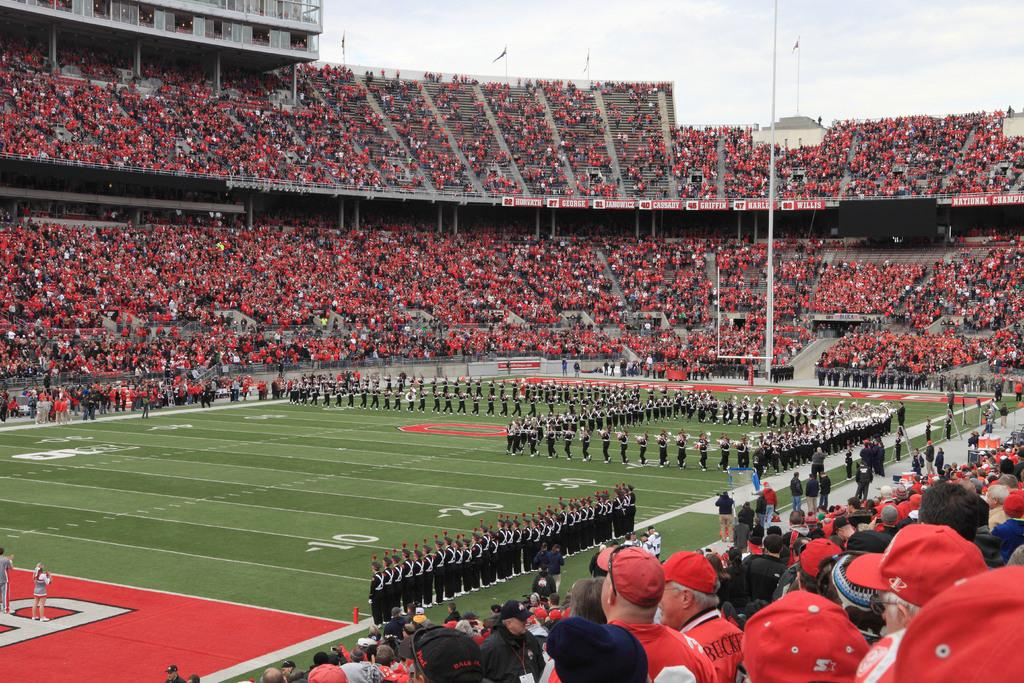What is the main subject of the image? The main subject of the image is a group of people on the ground. What objects can be seen in the image besides the people? There are poles, flags, boards, a fence, and a group of audience visible in the image. What is the condition of the sky in the image? The sky appears cloudy in the image. Can you tell me how many giants are present in the image? There are no giants present in the image; it features a group of people and various objects. What type of hall can be seen in the background of the image? There is no hall visible in the image; it primarily features a group of people, objects, and a cloudy sky. 